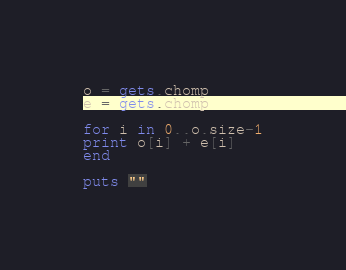<code> <loc_0><loc_0><loc_500><loc_500><_Ruby_>o = gets.chomp
e = gets.chomp

for i in 0..o.size-1
print o[i] + e[i]
end

puts ""
</code> 